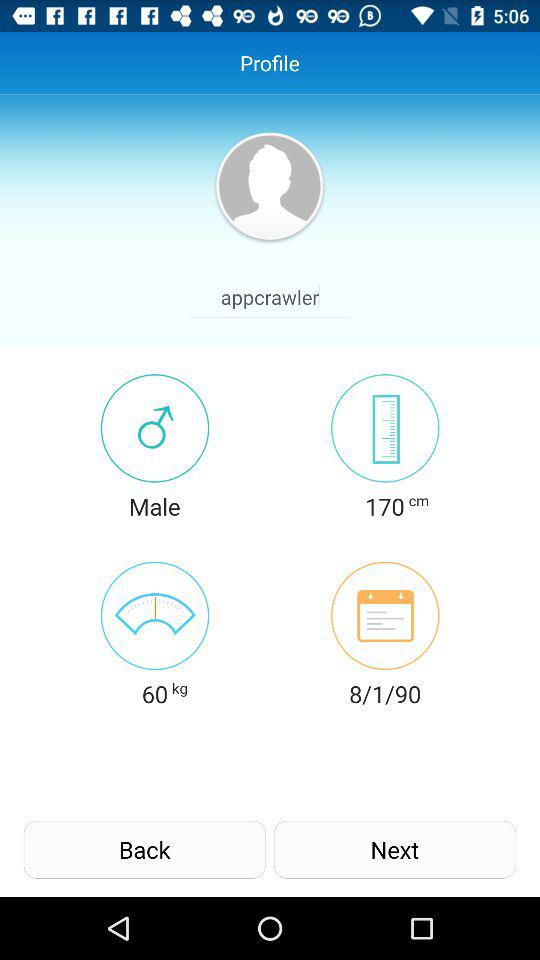What is the user's date of birth? The user's date of birth is January 8, 1990. 